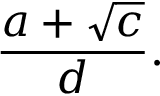Convert formula to latex. <formula><loc_0><loc_0><loc_500><loc_500>{ \frac { a + { \sqrt { c } } } { d } } .</formula> 